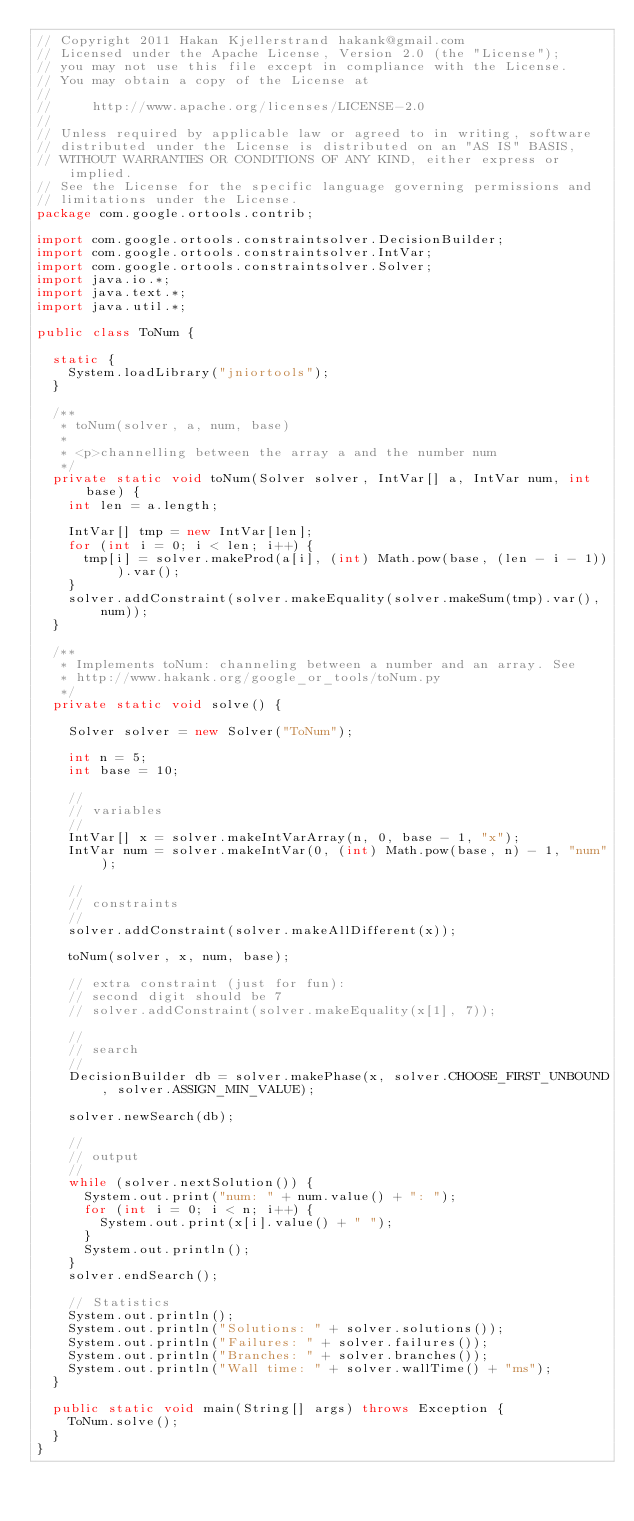<code> <loc_0><loc_0><loc_500><loc_500><_Java_>// Copyright 2011 Hakan Kjellerstrand hakank@gmail.com
// Licensed under the Apache License, Version 2.0 (the "License");
// you may not use this file except in compliance with the License.
// You may obtain a copy of the License at
//
//     http://www.apache.org/licenses/LICENSE-2.0
//
// Unless required by applicable law or agreed to in writing, software
// distributed under the License is distributed on an "AS IS" BASIS,
// WITHOUT WARRANTIES OR CONDITIONS OF ANY KIND, either express or implied.
// See the License for the specific language governing permissions and
// limitations under the License.
package com.google.ortools.contrib;

import com.google.ortools.constraintsolver.DecisionBuilder;
import com.google.ortools.constraintsolver.IntVar;
import com.google.ortools.constraintsolver.Solver;
import java.io.*;
import java.text.*;
import java.util.*;

public class ToNum {

  static {
    System.loadLibrary("jniortools");
  }

  /**
   * toNum(solver, a, num, base)
   *
   * <p>channelling between the array a and the number num
   */
  private static void toNum(Solver solver, IntVar[] a, IntVar num, int base) {
    int len = a.length;

    IntVar[] tmp = new IntVar[len];
    for (int i = 0; i < len; i++) {
      tmp[i] = solver.makeProd(a[i], (int) Math.pow(base, (len - i - 1))).var();
    }
    solver.addConstraint(solver.makeEquality(solver.makeSum(tmp).var(), num));
  }

  /**
   * Implements toNum: channeling between a number and an array. See
   * http://www.hakank.org/google_or_tools/toNum.py
   */
  private static void solve() {

    Solver solver = new Solver("ToNum");

    int n = 5;
    int base = 10;

    //
    // variables
    //
    IntVar[] x = solver.makeIntVarArray(n, 0, base - 1, "x");
    IntVar num = solver.makeIntVar(0, (int) Math.pow(base, n) - 1, "num");

    //
    // constraints
    //
    solver.addConstraint(solver.makeAllDifferent(x));

    toNum(solver, x, num, base);

    // extra constraint (just for fun):
    // second digit should be 7
    // solver.addConstraint(solver.makeEquality(x[1], 7));

    //
    // search
    //
    DecisionBuilder db = solver.makePhase(x, solver.CHOOSE_FIRST_UNBOUND, solver.ASSIGN_MIN_VALUE);

    solver.newSearch(db);

    //
    // output
    //
    while (solver.nextSolution()) {
      System.out.print("num: " + num.value() + ": ");
      for (int i = 0; i < n; i++) {
        System.out.print(x[i].value() + " ");
      }
      System.out.println();
    }
    solver.endSearch();

    // Statistics
    System.out.println();
    System.out.println("Solutions: " + solver.solutions());
    System.out.println("Failures: " + solver.failures());
    System.out.println("Branches: " + solver.branches());
    System.out.println("Wall time: " + solver.wallTime() + "ms");
  }

  public static void main(String[] args) throws Exception {
    ToNum.solve();
  }
}
</code> 